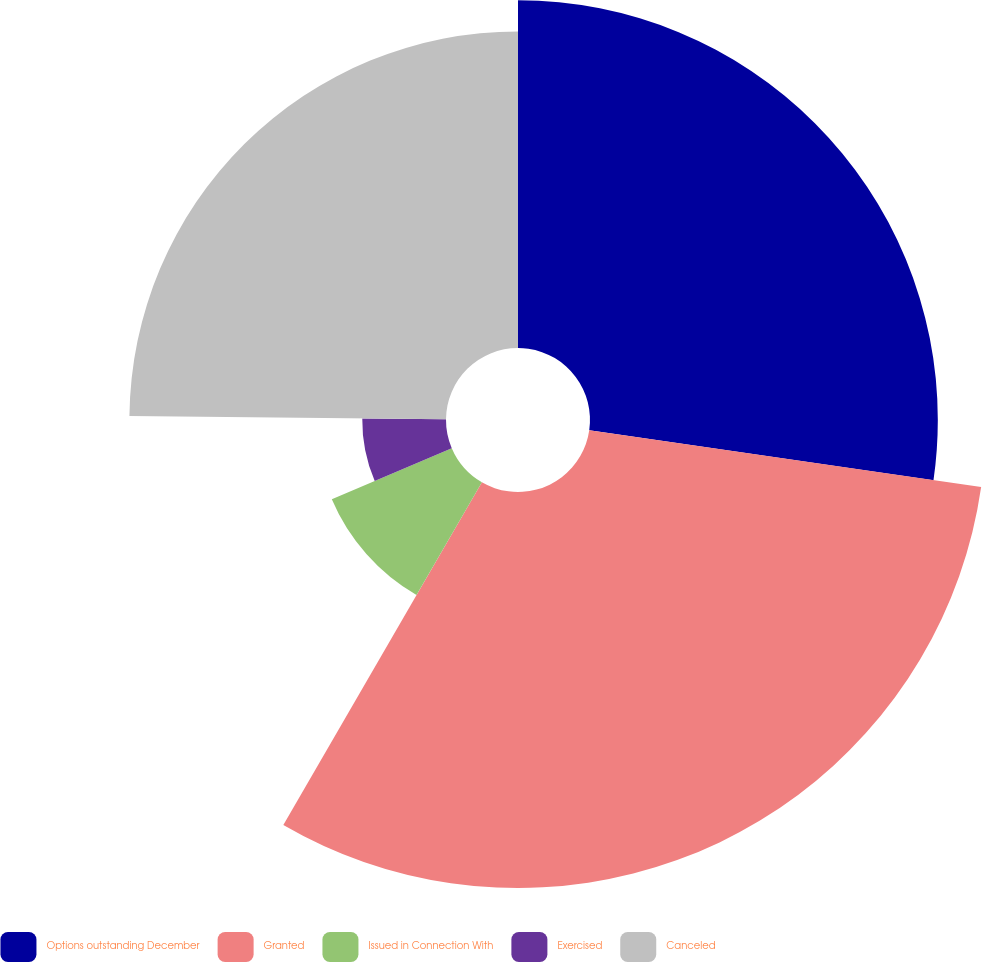Convert chart. <chart><loc_0><loc_0><loc_500><loc_500><pie_chart><fcel>Options outstanding December<fcel>Granted<fcel>Issued in Connection With<fcel>Exercised<fcel>Canceled<nl><fcel>27.29%<fcel>31.07%<fcel>10.23%<fcel>6.57%<fcel>24.84%<nl></chart> 